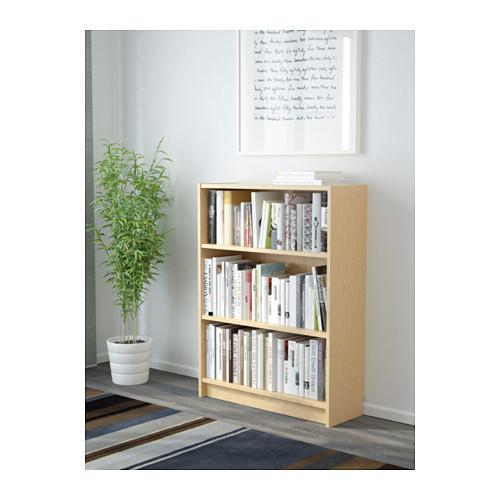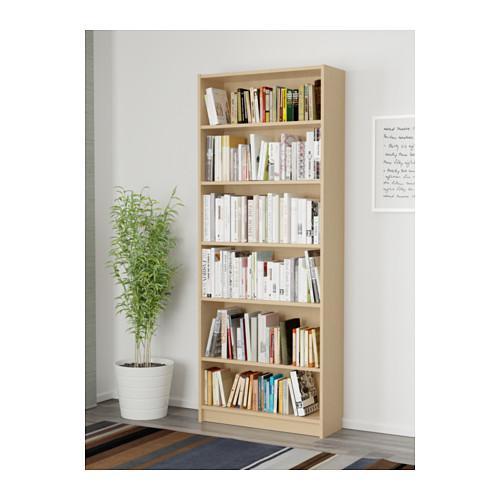The first image is the image on the left, the second image is the image on the right. Assess this claim about the two images: "A potted plant stands to the left of a bookshelf in each image.". Correct or not? Answer yes or no. Yes. The first image is the image on the left, the second image is the image on the right. For the images displayed, is the sentence "One of the shelves is six rows tall." factually correct? Answer yes or no. Yes. 